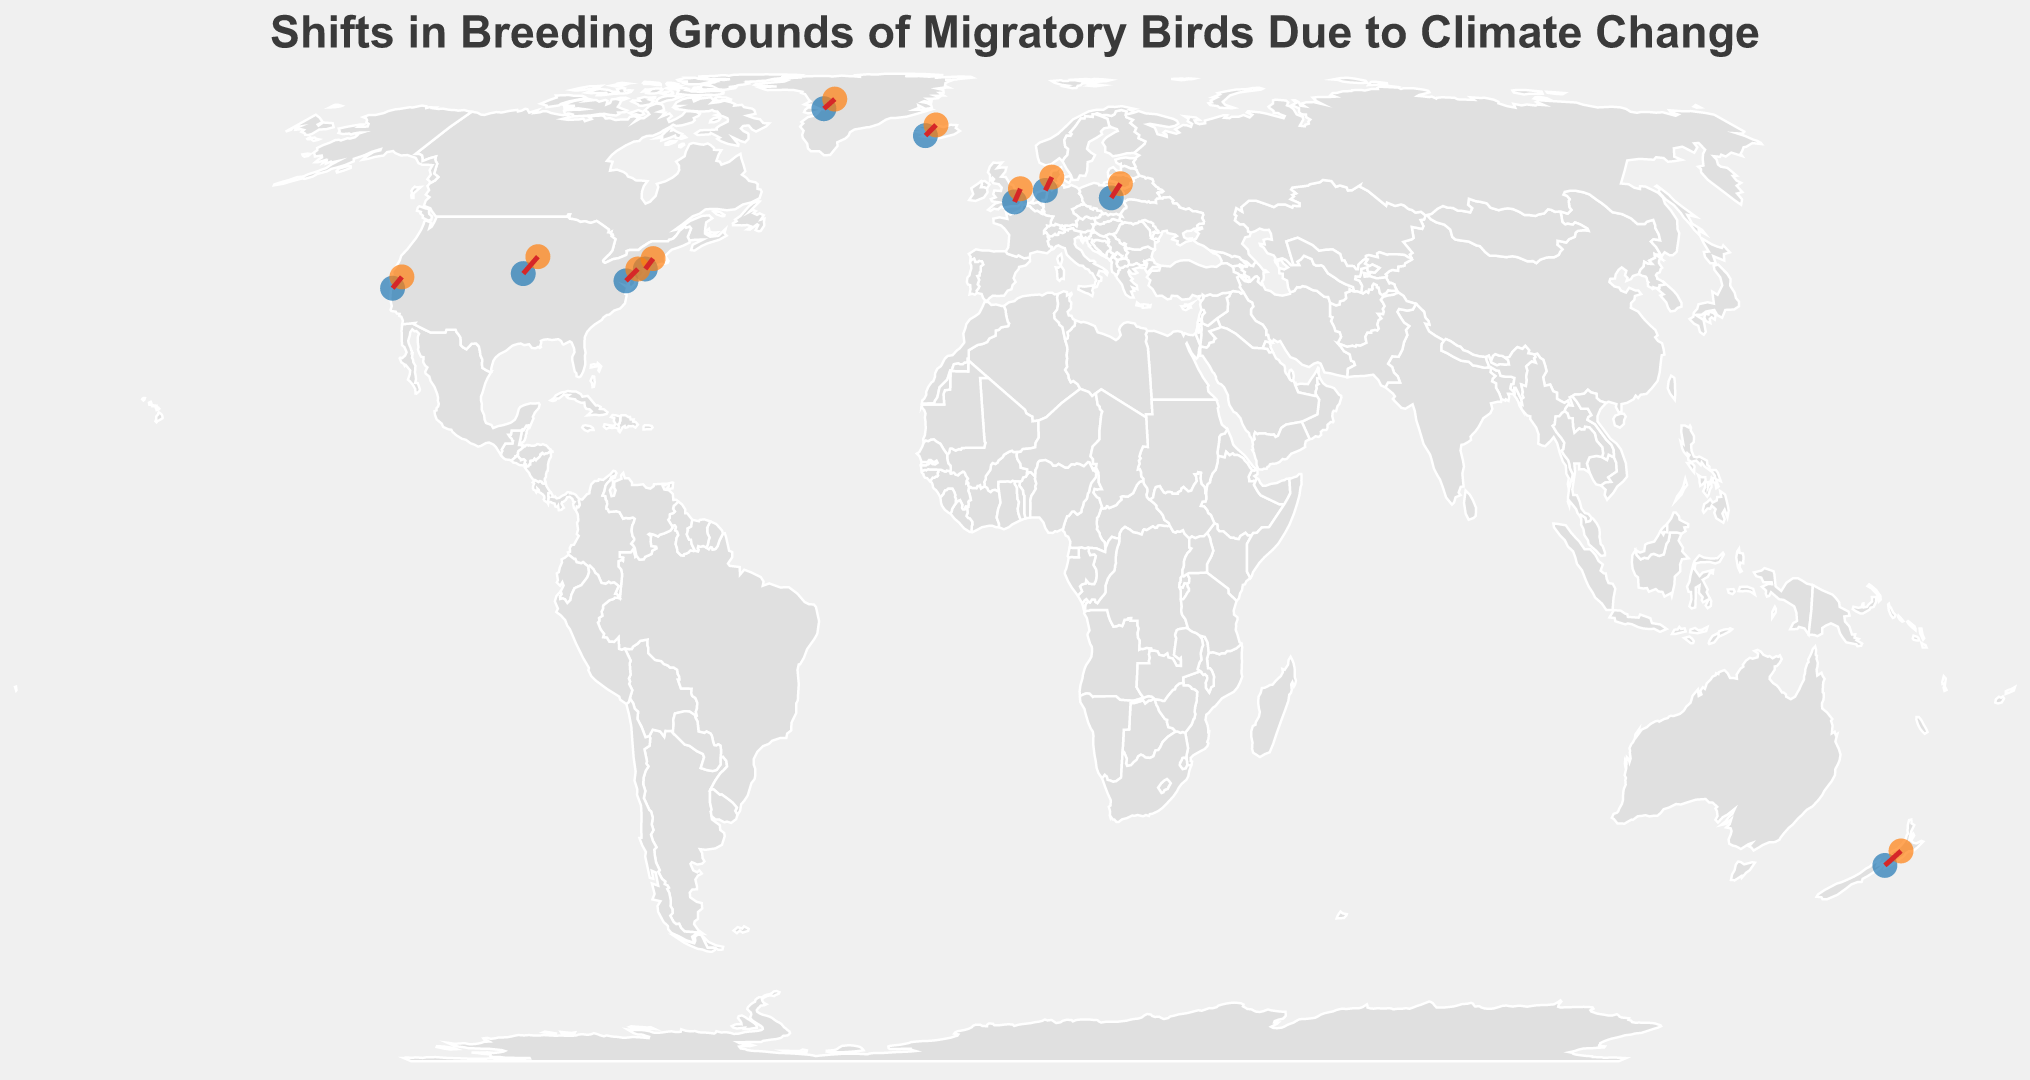What is the title of the figure? The title is usually displayed prominently at the top of the figure, in this case, it reads "Shifts in Breeding Grounds of Migratory Birds Due to Climate Change".
Answer: Shifts in Breeding Grounds of Migratory Birds Due to Climate Change How many bird species are shown in the figure? We can count the number of unique species listed in the data points. There are 10 unique species: Arctic Tern, Barn Swallow, Common Cuckoo, White Stork, Bar-tailed Godwit, Northern Wheatear, Osprey, Red Knot, Ruffous Hummingbird, Swainson's Hawk.
Answer: 10 Which bird species shows the northernmost shift in breeding grounds? Look at the new latitudes for all bird species and identify the highest value. The new latitude for the Arctic Tern is 73.2, which is the highest.
Answer: Arctic Tern What color represents the original breeding grounds on the map? Original breeding grounds are depicted as blue points on the map.
Answer: Blue What is the average latitude shift for the bird species shown? Calculate the shift in latitude for each species by taking the difference between the new and original latitudes. Then, compute the average of these shifts. For example, Arctic Tern: 73.2 - 70.5 = 2.7, Barn Swallow: 42.3 - 40.7 = 1.6, and so forth. Summing these differences and dividing by the number of species gives us the average shift.
Answer: 2.52 Which species moved the furthest south? Compare the new latitudes to see which species has moved to the southernmost point. Bar-tailed Godwit with a new latitude of -39.1 is the southernmost.
Answer: Bar-tailed Godwit How many bird species are represented in the European continent based on their original breeding grounds? Identify the species whose original latitudes and longitudes place them in Europe. Barn Swallow, Common Cuckoo, White Stork, and Red Knot have original coordinates in Europe.
Answer: 4 Which bird species shows a shift towards the east? Compare the new and original longitudes to find the species that have a positive change (moved towards the east). Species include Barn Swallow, Common Cuckoo, White Stork, Bar-tailed Godwit, and Red Knot.
Answer: Five species (Barn Swallow, Common Cuckoo, White Stork, Bar-tailed Godwit, Red Knot) Which species exhibits the greatest change in latitude? Calculate the latitude difference between original and new coordinates. Northern Wheatear exhibits the greatest change of 2.4.
Answer: Northern Wheatear 